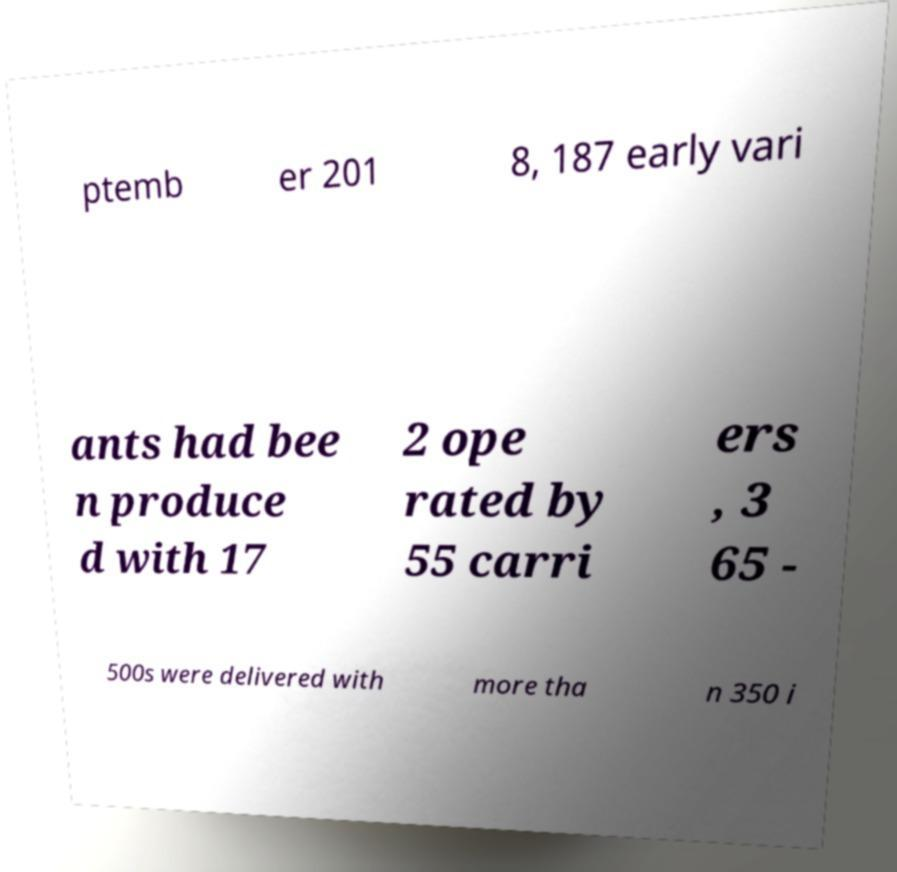For documentation purposes, I need the text within this image transcribed. Could you provide that? ptemb er 201 8, 187 early vari ants had bee n produce d with 17 2 ope rated by 55 carri ers , 3 65 - 500s were delivered with more tha n 350 i 